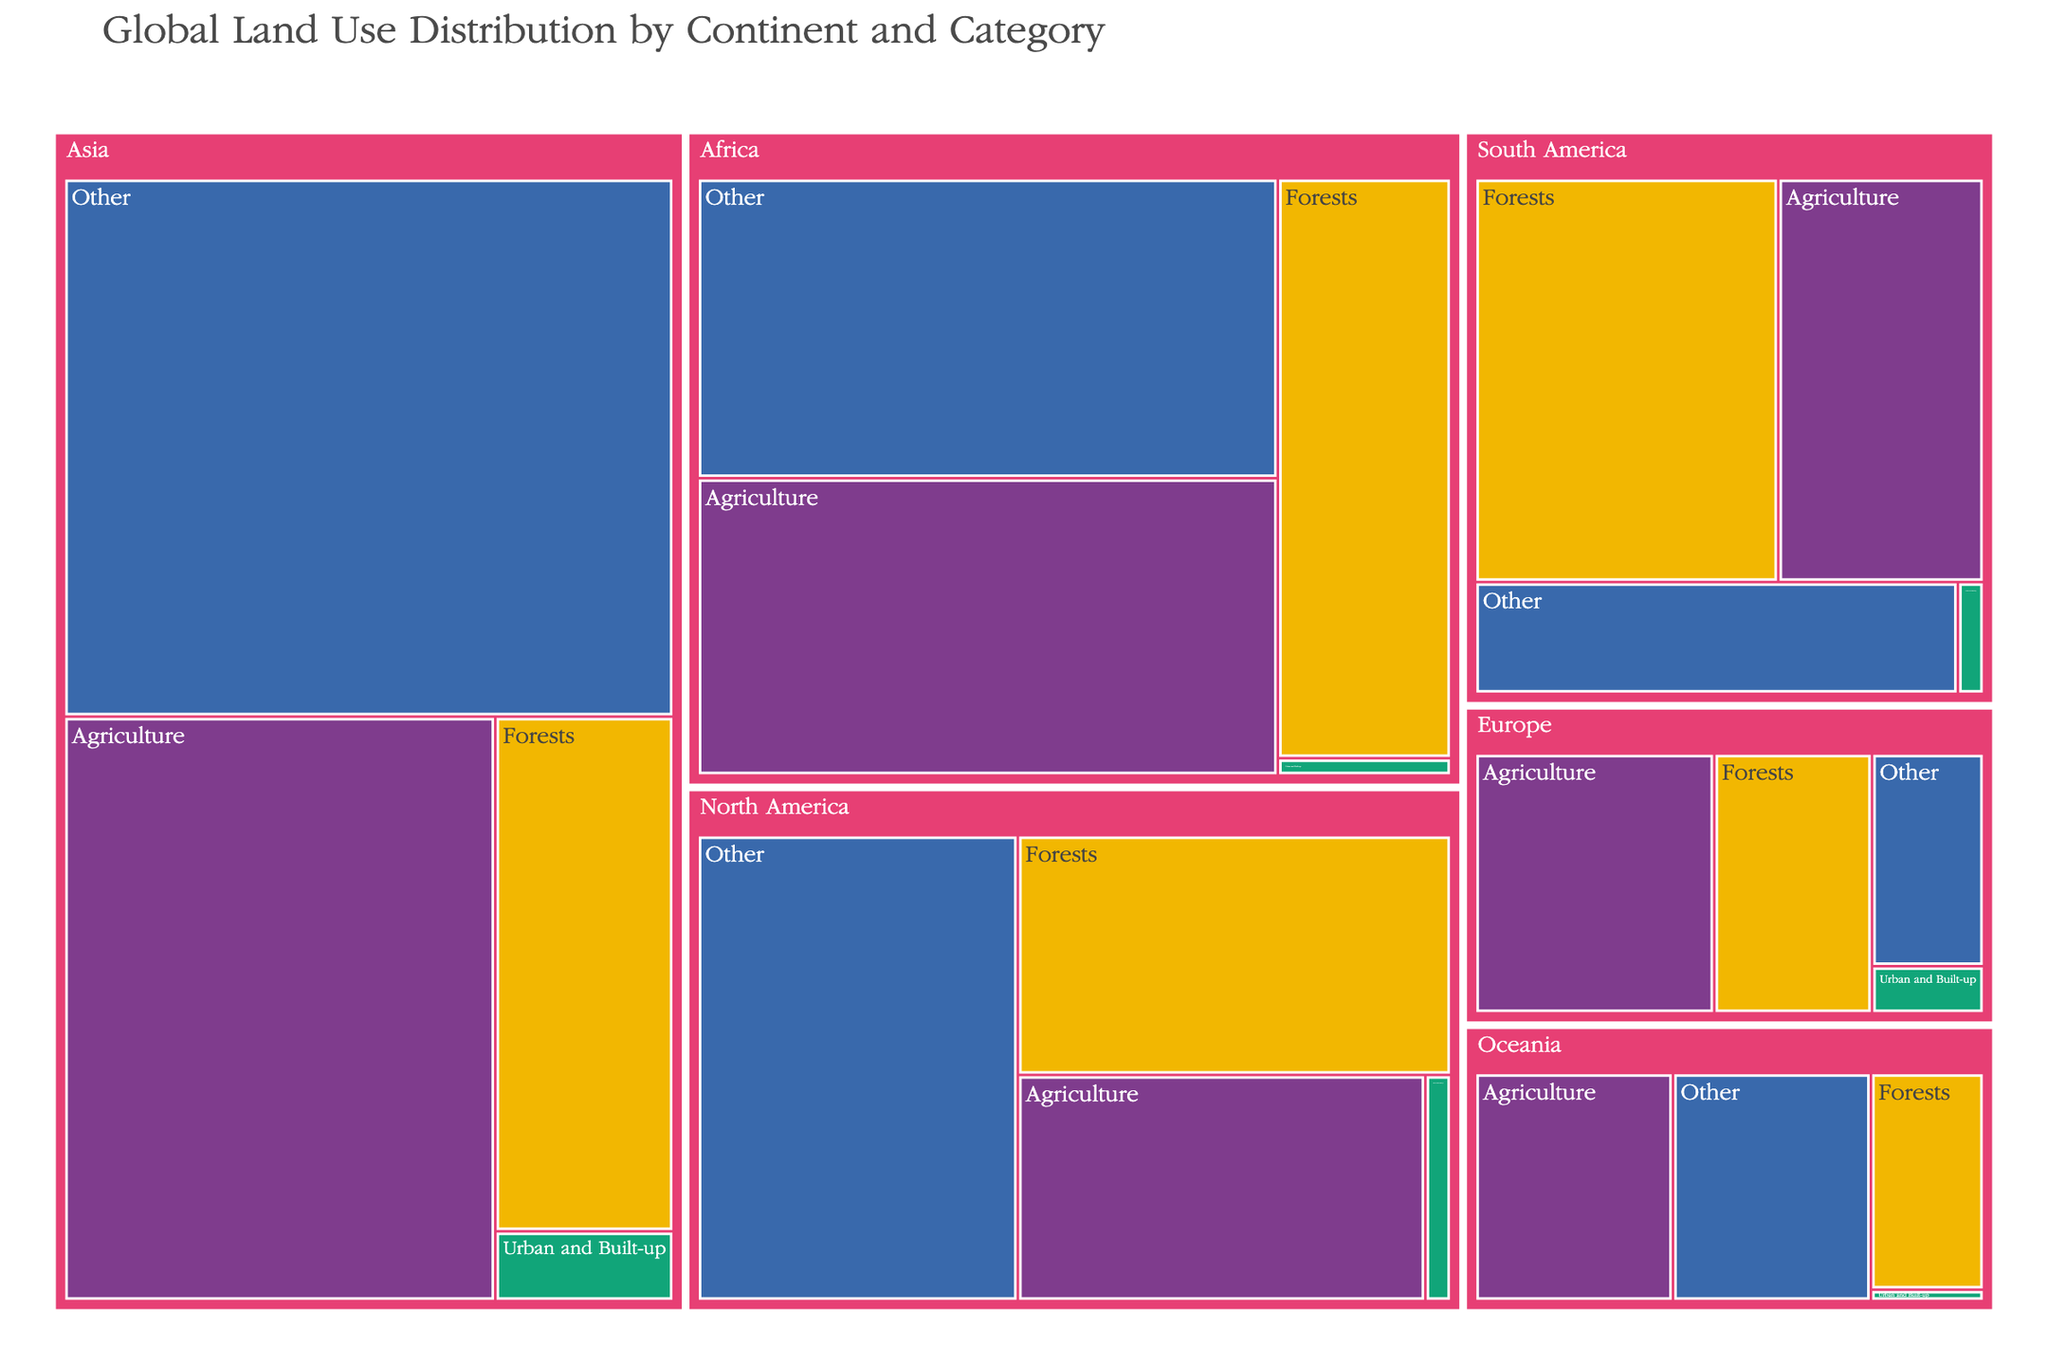What is the total area of forests in South America? To find the total area of forests in South America, look at the "Forests" section within the "South America" part of the Treemap. This value is represented as 8.4 million square kilometers.
Answer: 8.4 million sq km Which continent has the largest area dedicated to agriculture? Compare the areas dedicated to agriculture for all the continents: Asia (16.2), Africa (11.5), North America (6.3), South America (5.7), Europe (4.7), and Oceania (3.5). Asia has the largest area at 16.2 million sq km.
Answer: Asia What is the area difference between urban areas in Asia and Europe? Find the areas for "Urban and Built-up" in both Asia (0.8) and Europe (0.4). Subtract Europe's value from Asia's value: 0.8 - 0.4 = 0.4 million square kilometers.
Answer: 0.4 million sq km Which category has the smallest area in Africa? Check the areas for all categories in Africa: Forests (6.7), Agriculture (11.5), Urban and Built-up (0.2), and Other (11.6). "Urban and Built-up" with 0.2 million sq km is the smallest.
Answer: Urban and Built-up Rank the continents from highest to lowest in terms of "Other" land use area. Compare the "Other" areas across continents: Asia (21.1), Africa (11.6), North America (10.2), South America (3.7), Europe (1.8), and Oceania (3.5). The ranking from highest to lowest is Asia, Africa, North America, South America, Oceania, and Europe.
Answer: Asia, Africa, North America, South America, Oceania, Europe What is the combined area of agriculture and forests in Europe? Add the areas for agriculture (4.7) and forests (3.1) in Europe: 4.7 + 3.1 = 7.8 million square kilometers.
Answer: 7.8 million sq km Which continent has the highest total area combining all categories? Calculate the total areas for each continent by summing all categories: 
- Asia: 5.9 (Forests) + 16.2 (Agriculture) + 0.8 (Urban) + 21.1 (Other) = 44.0
- Africa: 6.7 + 11.5 + 0.2 + 11.6 = 30.0
- North America: 7.1 + 6.3 + 0.4 + 10.2 = 24.0
- South America: 8.4 + 5.7 + 0.2 + 3.7 = 18.0
- Europe: 3.1 + 4.7 + 0.4 + 1.8 = 10.0
- Oceania: 1.9 + 3.5 + 0.1 + 3.5 = 9.0
Asia has the highest total area.
Answer: Asia What proportion of Oceania's land is used for agriculture? Calculate Oceania's total land area: 1.9 (Forests) + 3.5 (Agriculture) + 0.1 (Urban) + 3.5 (Other) = 9.0. Then find the proportion of agriculture: 3.5 / 9.0 ≈ 0.39, or 39%.
Answer: 39% What is the predominant land use in North America? Compare the land use categories in North America: Forests (7.1), Agriculture (6.3), Urban and Built-up (0.4), Other (10.2). The "Other" category is the largest at 10.2 million sq km.
Answer: Other 